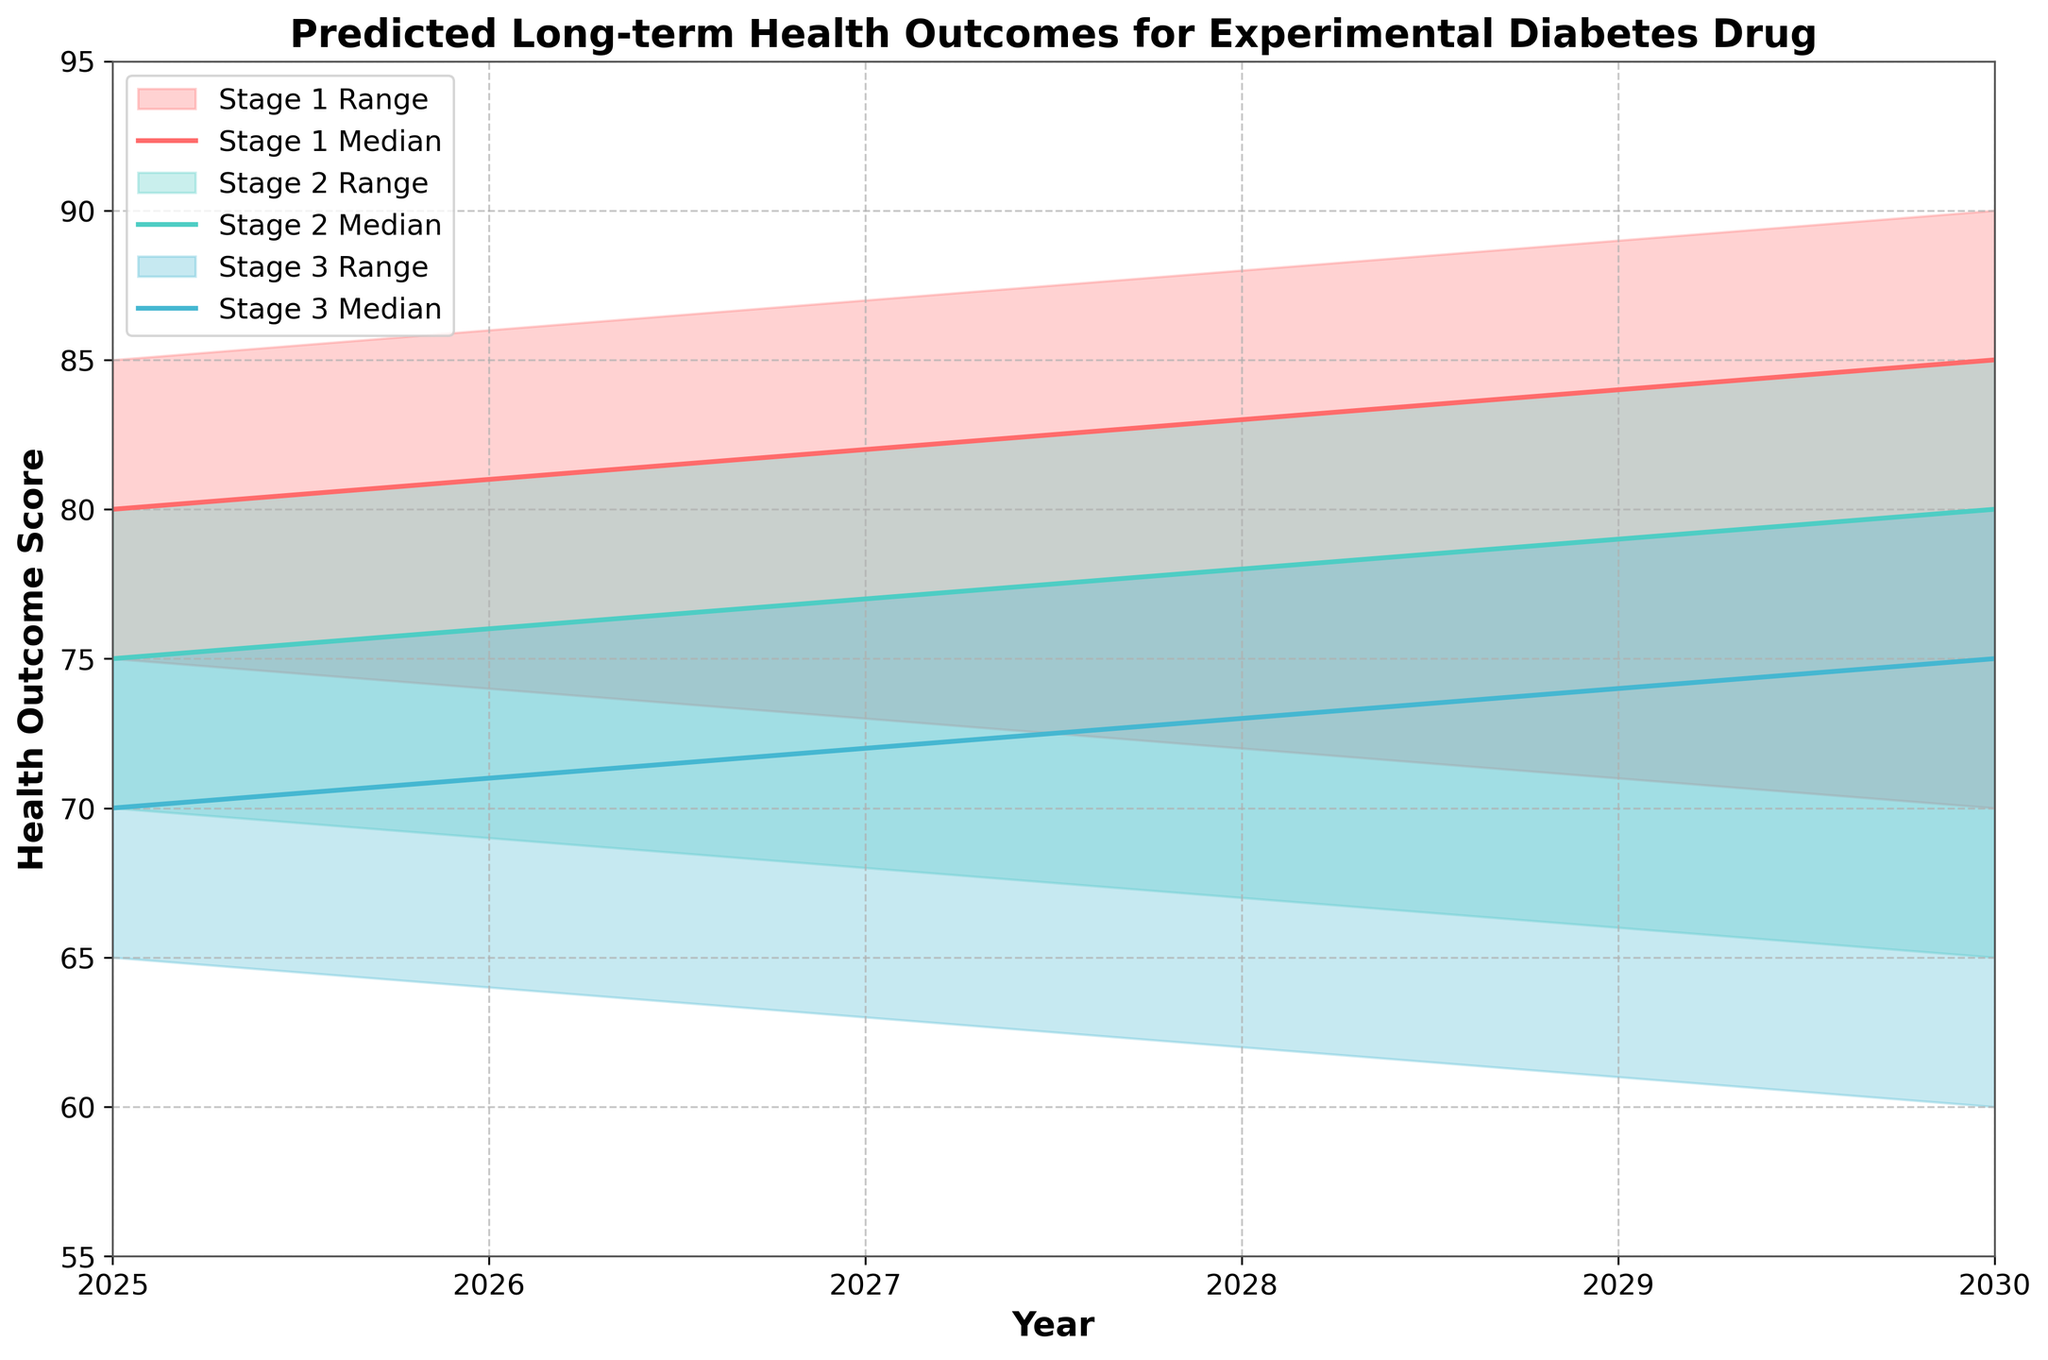What is the title of the figure? The title is located at the top of the figure and reads "Predicted Long-term Health Outcomes for Experimental Diabetes Drug".
Answer: Predicted Long-term Health Outcomes for Experimental Diabetes Drug What are the years represented on the x-axis? The years are represented on the x-axis, ranging from 2025 to 2030.
Answer: 2025 to 2030 What is the health outcome score range on the y-axis? The y-axis shows the health outcome scores ranging from 55 to 95.
Answer: 55 to 95 For Stage 1, what is the median health outcome score in the year 2027? The median score for Stage 1 in 2027 is given directly in the data, represented by the middle curve of Stage 1.
Answer: 82 What are the colors used to represent each stage in the figure? The colors for each stage are observed directly on the plot: Stage 1 is red, Stage 2 is turquoise, and Stage 3 is light blue.
Answer: Stage 1: red; Stage 2: turquoise; Stage 3: light blue How does the median health outcome score change for Stage 2 from 2025 to 2030? The median scores for Stage 2 are 75 in 2025 and 80 in 2030. The change is 80 - 75.
Answer: It increases by 5 points In which year is the lower bound for Stage 3 the lowest, and what is the score? The lowest lower bound for Stage 3 occurs in 2030 with a score of 60, as seen at the bottom of the shaded area for Stage 3.
Answer: 2030, 60 Compare the median health outcome scores for Stage 1 and Stage 3 in the year 2029. From the data, the median scores for 2029 are 84 for Stage 1 and 74 for Stage 3.
Answer: Stage 1: 84; Stage 3: 74 Between 2025 and 2030, which stage shows the greatest increase in the median health outcome score? By comparing the changes in the median scores: Stage 1 increases from 80 to 85 (5 points), Stage 2 from 75 to 80 (5 points), and Stage 3 from 70 to 75 (5 points). All stages increase by 5 points.
Answer: All stages What trend can be observed in the health outcome scores for Stage 2 over the years? The figure shows an overall upward trend in the median, lower, and upper bounds for Stage 2 from 2025 to 2030.
Answer: Upward trend 